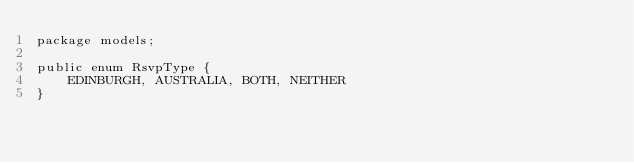<code> <loc_0><loc_0><loc_500><loc_500><_Java_>package models;

public enum RsvpType {
	EDINBURGH, AUSTRALIA, BOTH, NEITHER
}
</code> 